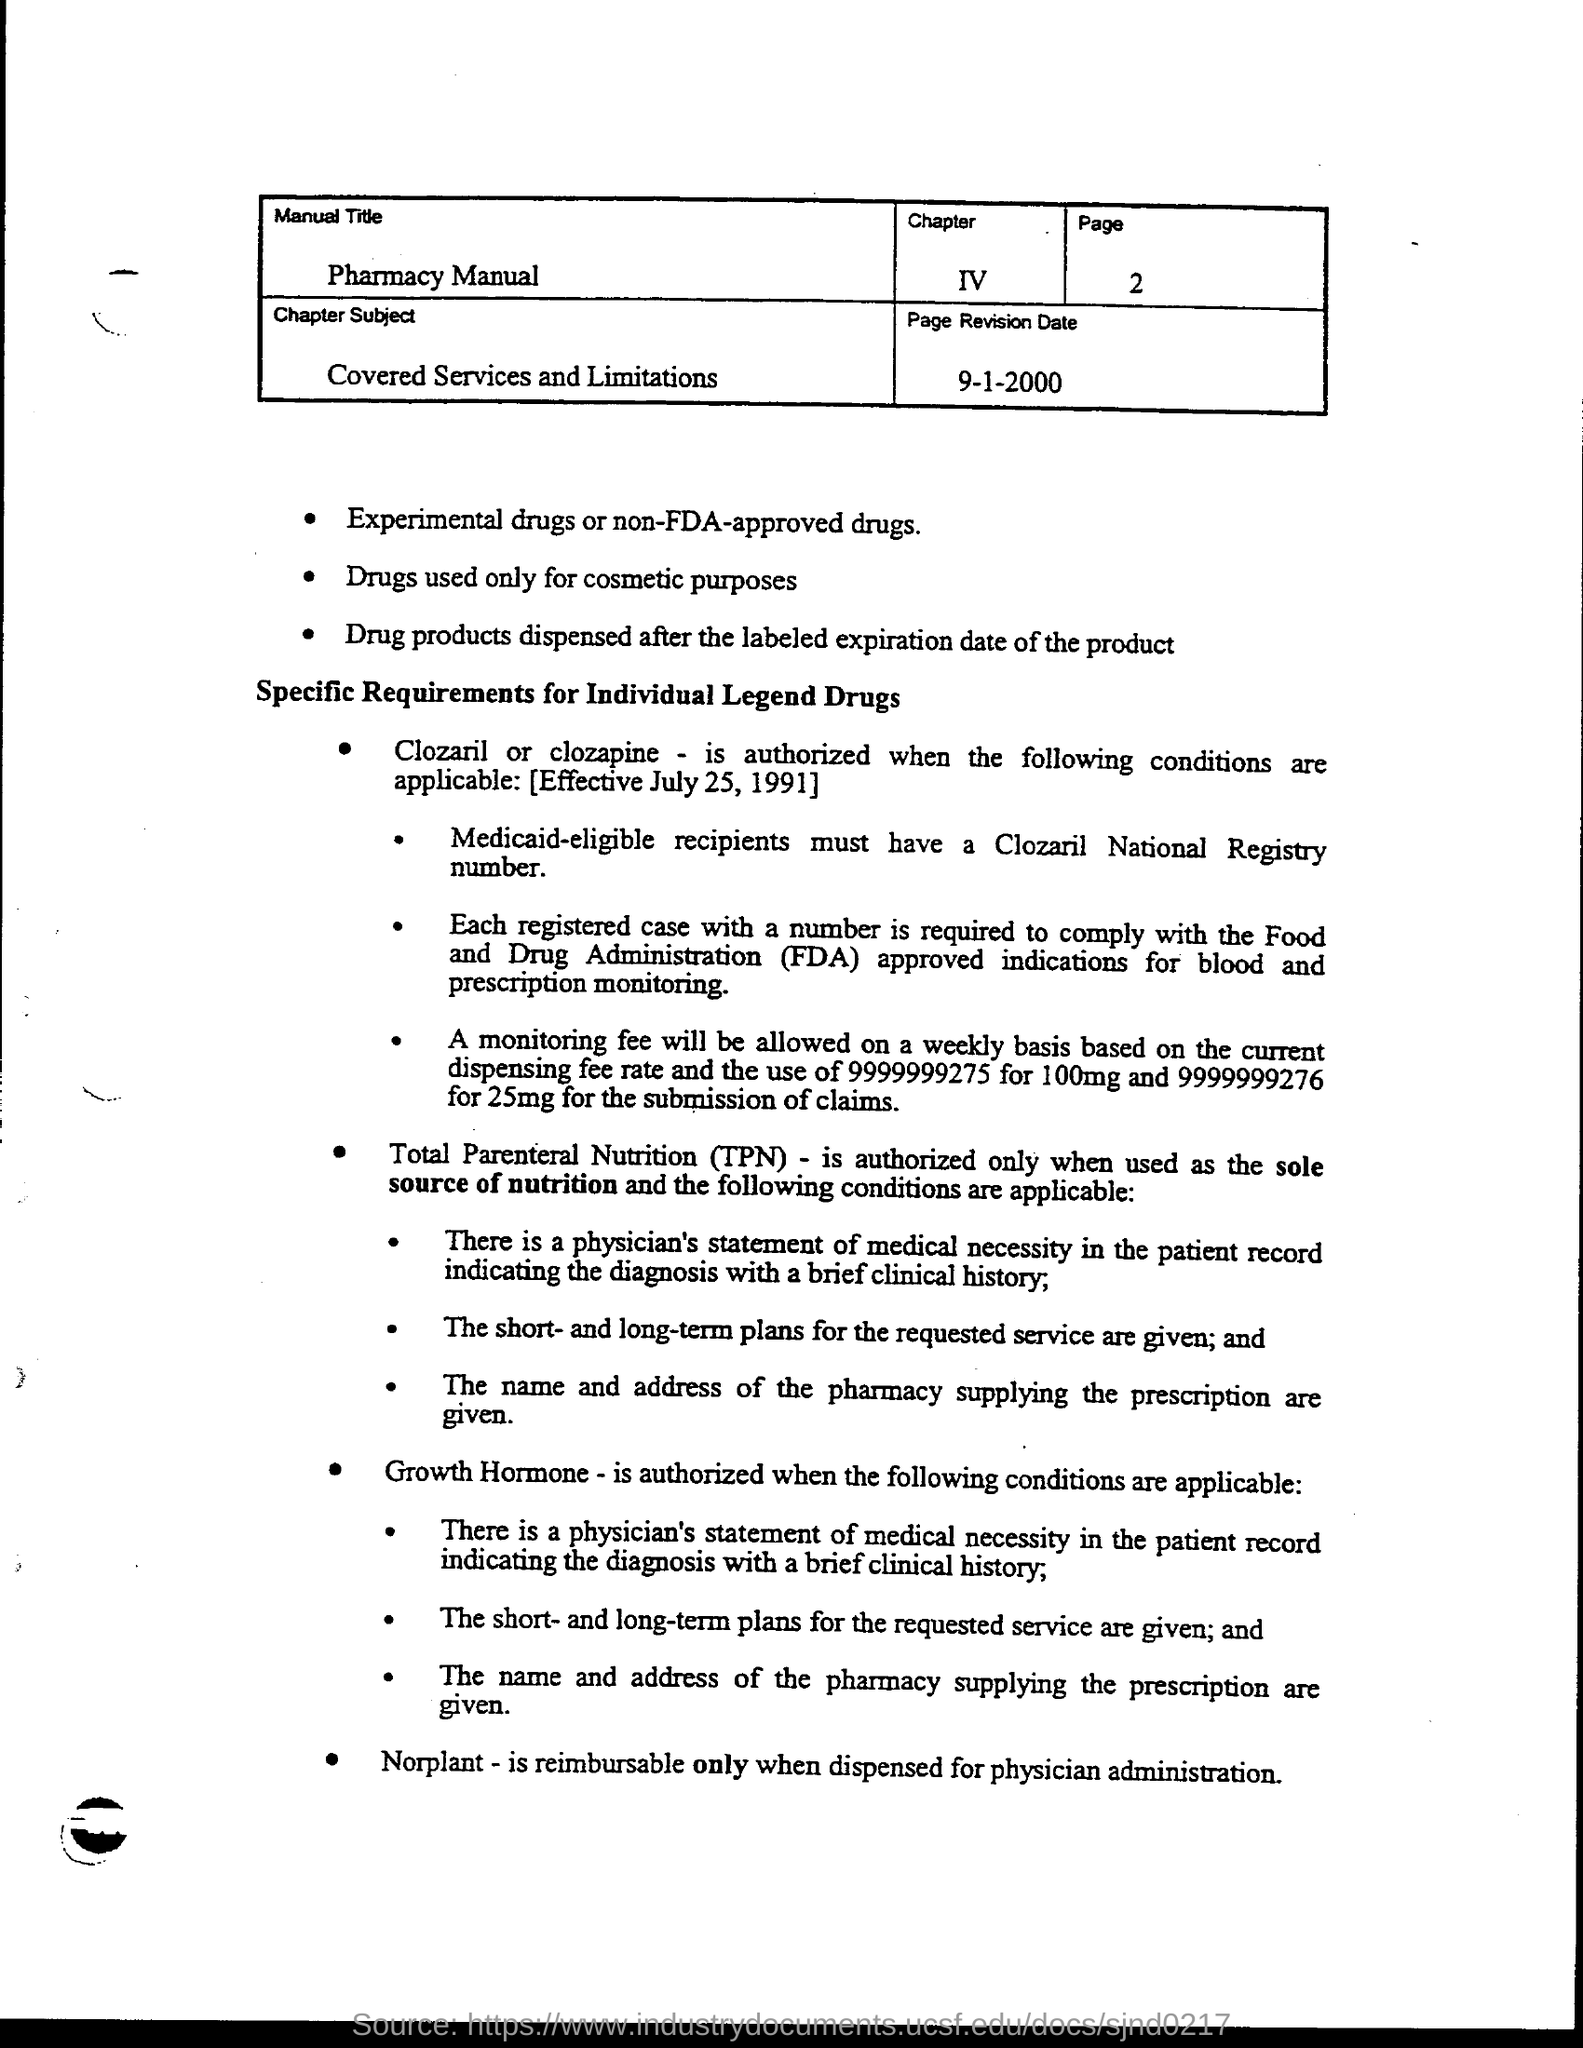What is the manual title ?
Ensure brevity in your answer.  Pharmacy manual. What is the chapter number ?
Provide a short and direct response. Chapter iv. What is the page no.?
Provide a succinct answer. 2. What is the chapter subject?
Offer a terse response. Covered Services and Limitations. What is the page revision date?
Your answer should be compact. 9-1-2000. What does fda stand for ?
Provide a short and direct response. Food and Drug Administration. 